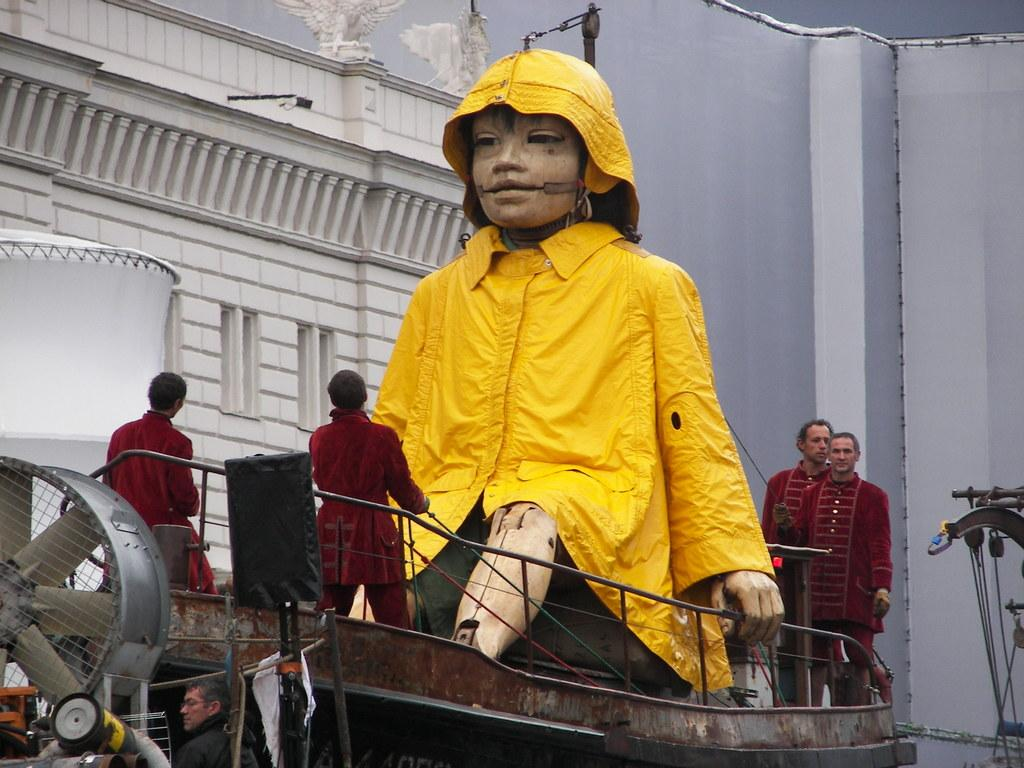What can be seen at the bottom of the image? There are persons standing at the bottom of the image. What is the main subject in the middle of the image? There is a depiction of a person in the middle of the image. What is visible in the background of the image? There is a wall in the background of the image. Can you tell me how many shops are visible in the image? There is no shop present in the image. What type of comfort can be seen being provided by the person in the middle of the image? There is no indication of comfort being provided in the image; it only depicts a person. 